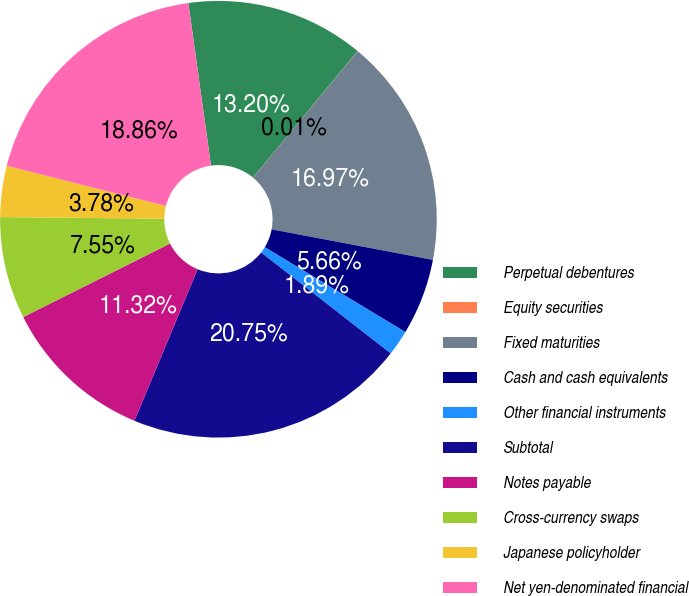<chart> <loc_0><loc_0><loc_500><loc_500><pie_chart><fcel>Perpetual debentures<fcel>Equity securities<fcel>Fixed maturities<fcel>Cash and cash equivalents<fcel>Other financial instruments<fcel>Subtotal<fcel>Notes payable<fcel>Cross-currency swaps<fcel>Japanese policyholder<fcel>Net yen-denominated financial<nl><fcel>13.2%<fcel>0.01%<fcel>16.97%<fcel>5.66%<fcel>1.89%<fcel>20.75%<fcel>11.32%<fcel>7.55%<fcel>3.78%<fcel>18.86%<nl></chart> 